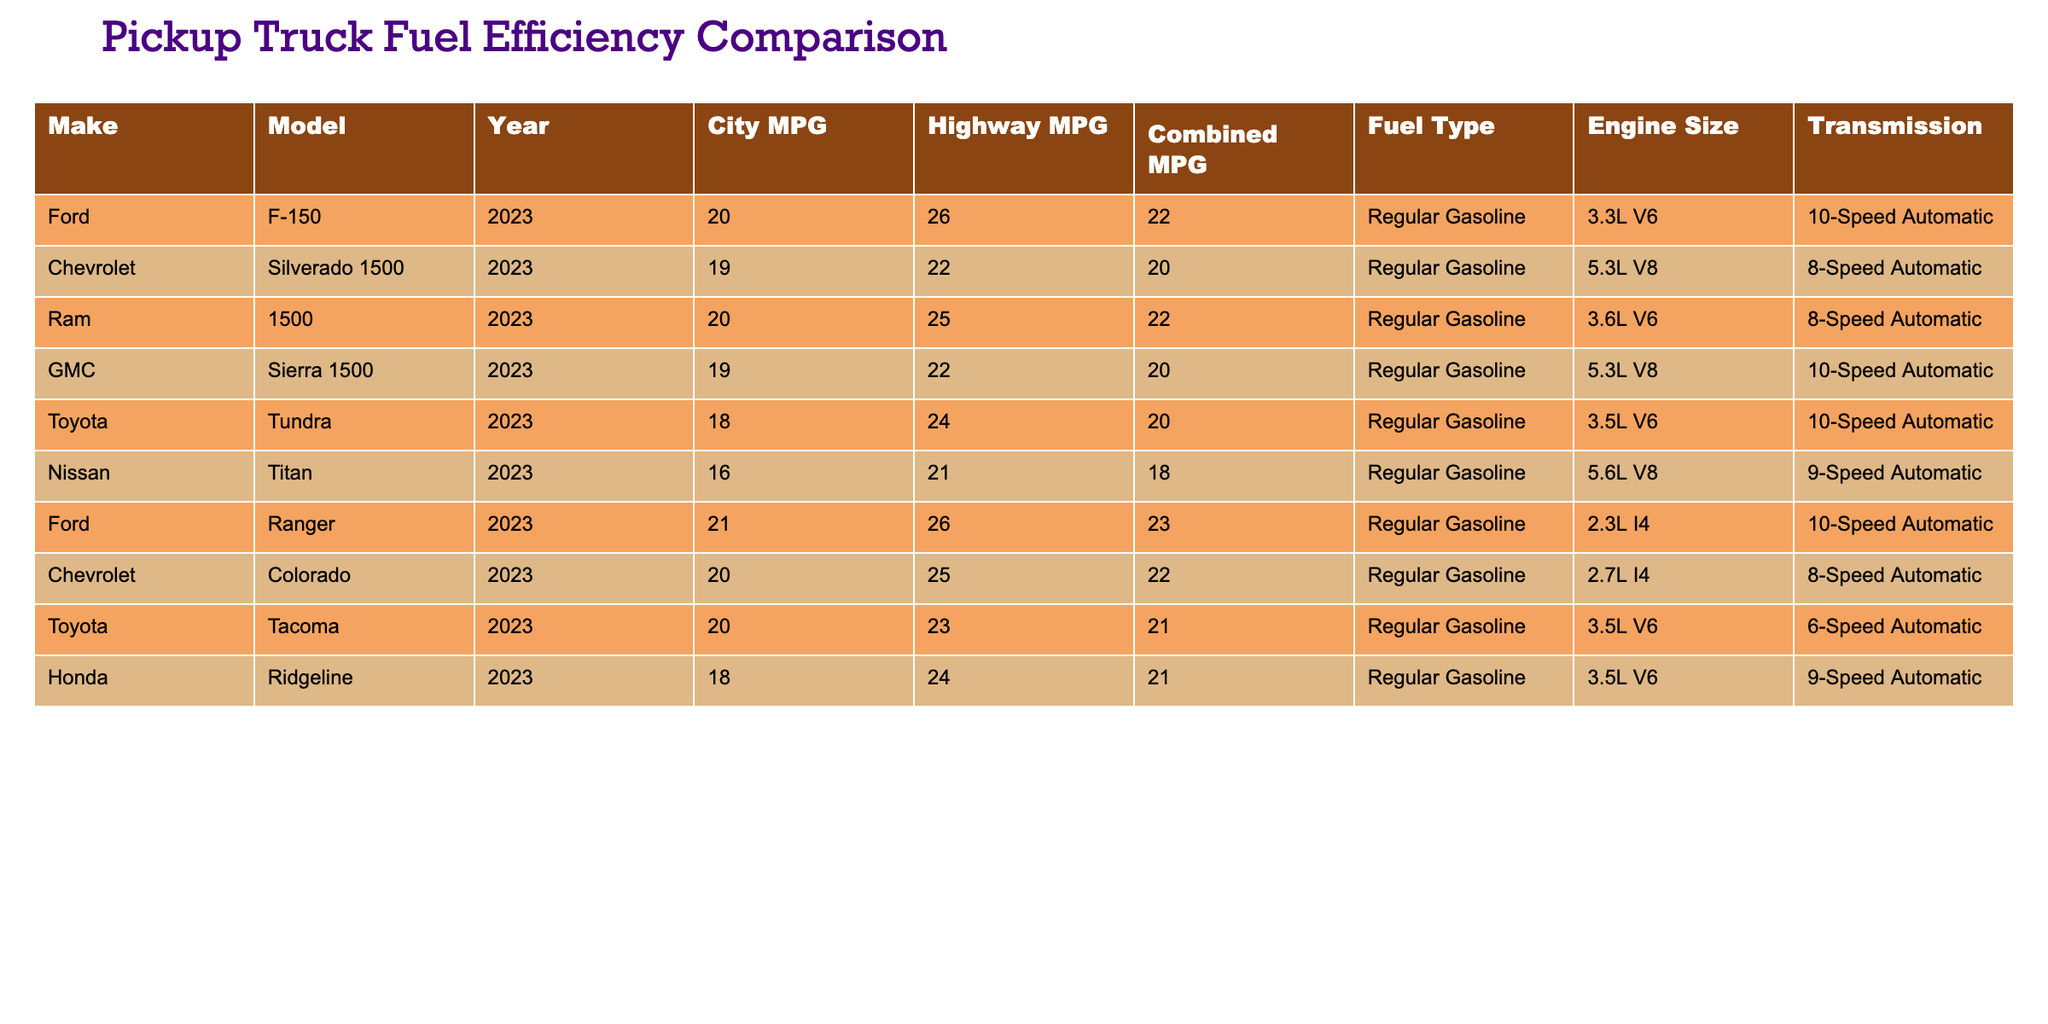What is the city MPG of the Ford F-150? According to the table, the city MPG for the Ford F-150 is listed under the "City MPG" column for the row corresponding to Ford F-150, which shows a value of 20.
Answer: 20 Which pickup truck has the highest highway MPG? By inspecting the "Highway MPG" column, I can see that both the Ford Ranger and the Ford F-150 achieve the highest value of 26, thus making them tied for the highest highway MPG.
Answer: Ford Ranger and Ford F-150 Is the Toyota Tundra more fuel-efficient than the Nissan Titan in terms of combined MPG? To compare, I check the "Combined MPG" column where the Toyota Tundra has a value of 20 and the Nissan Titan has a value of 18. Since 20 is greater than 18, the Toyota Tundra is indeed more fuel-efficient than the Nissan Titan in combined MPG.
Answer: Yes What is the average city MPG of all vehicles listed in the table? To find the average city MPG, I first add the city MPG values: 20 (F-150) + 19 (Silverado) + 20 (1500) + 19 (Sierra) + 18 (Tundra) + 16 (Titan) + 21 (Ranger) + 20 (Colorado) + 20 (Tacoma) + 18 (Ridgeline) =  200. There are 10 vehicles, so I divide the total sum by 10: 200/10 = 20.
Answer: 20 Which transmission type is most common among the trucks? Looking through the "Transmission" column, I can count the occurrence of each type. "10-Speed Automatic" appears 4 times, "8-Speed Automatic" 3 times, "9-Speed Automatic" 2 times, and "6-Speed Automatic" 1 time. Therefore, "10-Speed Automatic" is the most common transmission type.
Answer: 10-Speed Automatic Is the combined MPG of the Chevrolet Silverado 1500 less than that of the Ram 1500? In the "Combined MPG" column, I can see that the Chevrolet Silverado 1500 has a value of 20, whereas the Ram 1500 has a value of 22. Since 20 is less than 22, it is confirmed that the Silverado is less fuel-efficient.
Answer: Yes What is the combined MPG difference between the Ford Ranger and the GMC Sierra 1500? The combined MPG for the Ford Ranger is 23, while for the GMC Sierra 1500 it is 20. I subtract the GMC's value from the Ranger's: 23 - 20 = 3, giving a difference of 3 in combined MPG between them.
Answer: 3 Which truck has the largest engine size among the listed models? By examining the "Engine Size" column, I compare the engine sizes listed: 3.3L, 5.3L, 3.6L, 5.3L, 3.5L, 5.6L, 2.3L, 2.7L, and 3.5L. The Nissan Titan has the largest engine size at 5.6L.
Answer: Nissan Titan 